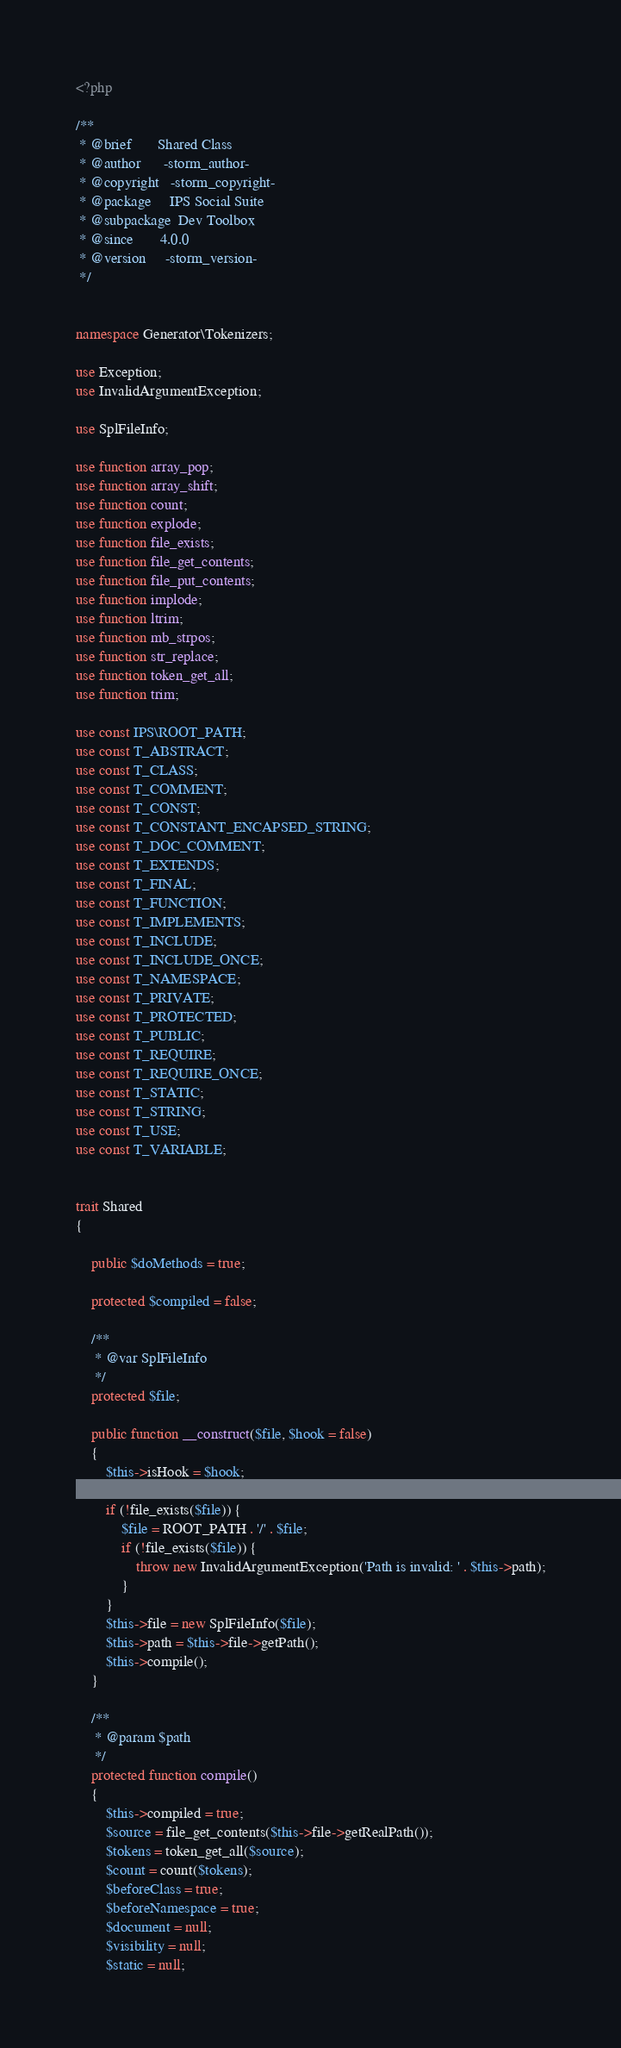Convert code to text. <code><loc_0><loc_0><loc_500><loc_500><_PHP_><?php

/**
 * @brief       Shared Class
 * @author      -storm_author-
 * @copyright   -storm_copyright-
 * @package     IPS Social Suite
 * @subpackage  Dev Toolbox
 * @since       4.0.0
 * @version     -storm_version-
 */


namespace Generator\Tokenizers;

use Exception;
use InvalidArgumentException;

use SplFileInfo;

use function array_pop;
use function array_shift;
use function count;
use function explode;
use function file_exists;
use function file_get_contents;
use function file_put_contents;
use function implode;
use function ltrim;
use function mb_strpos;
use function str_replace;
use function token_get_all;
use function trim;

use const IPS\ROOT_PATH;
use const T_ABSTRACT;
use const T_CLASS;
use const T_COMMENT;
use const T_CONST;
use const T_CONSTANT_ENCAPSED_STRING;
use const T_DOC_COMMENT;
use const T_EXTENDS;
use const T_FINAL;
use const T_FUNCTION;
use const T_IMPLEMENTS;
use const T_INCLUDE;
use const T_INCLUDE_ONCE;
use const T_NAMESPACE;
use const T_PRIVATE;
use const T_PROTECTED;
use const T_PUBLIC;
use const T_REQUIRE;
use const T_REQUIRE_ONCE;
use const T_STATIC;
use const T_STRING;
use const T_USE;
use const T_VARIABLE;


trait Shared
{

    public $doMethods = true;

    protected $compiled = false;

    /**
     * @var SplFileInfo
     */
    protected $file;

    public function __construct($file, $hook = false)
    {
        $this->isHook = $hook;

        if (!file_exists($file)) {
            $file = ROOT_PATH . '/' . $file;
            if (!file_exists($file)) {
                throw new InvalidArgumentException('Path is invalid: ' . $this->path);
            }
        }
        $this->file = new SplFileInfo($file);
        $this->path = $this->file->getPath();
        $this->compile();
    }

    /**
     * @param $path
     */
    protected function compile()
    {
        $this->compiled = true;
        $source = file_get_contents($this->file->getRealPath());
        $tokens = token_get_all($source);
        $count = count($tokens);
        $beforeClass = true;
        $beforeNamespace = true;
        $document = null;
        $visibility = null;
        $static = null;</code> 